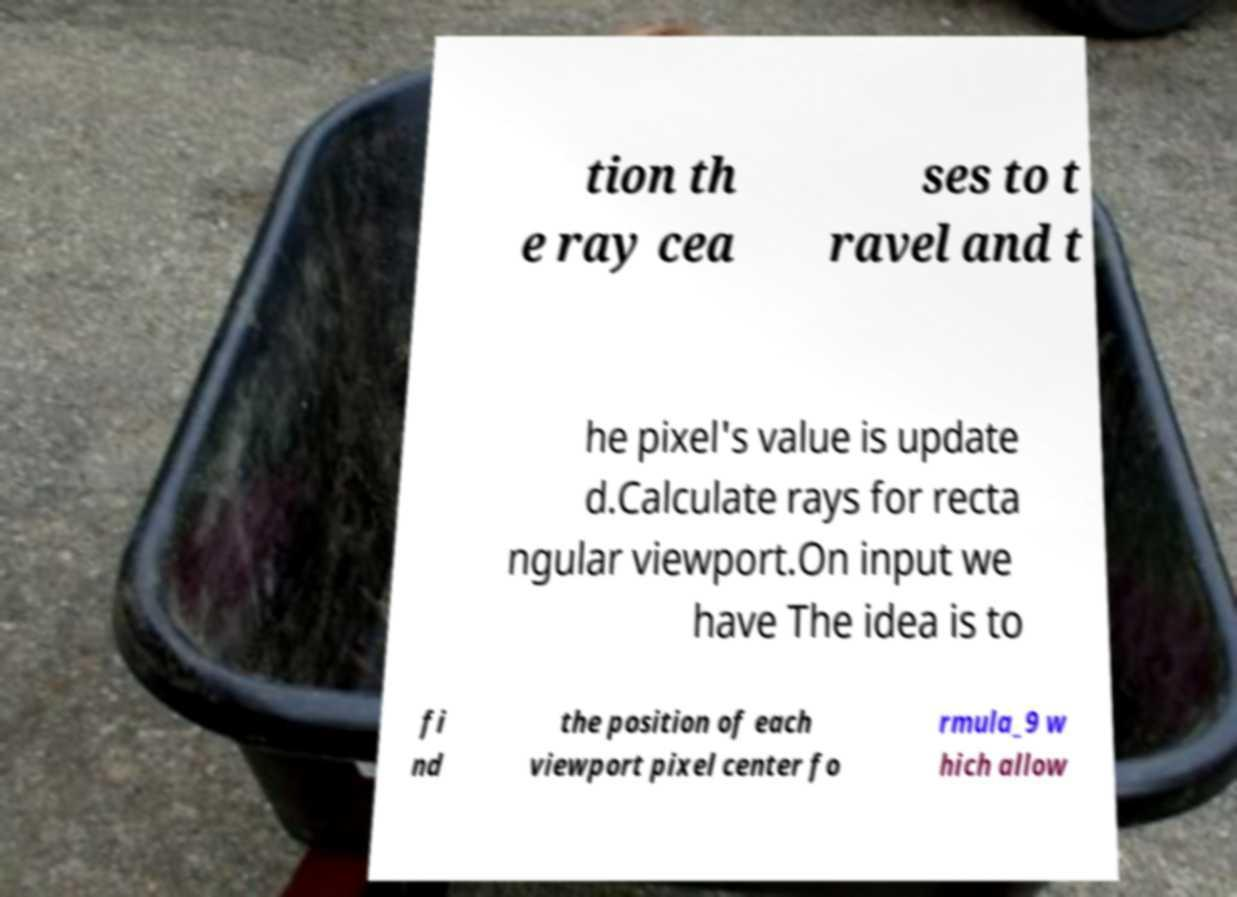For documentation purposes, I need the text within this image transcribed. Could you provide that? tion th e ray cea ses to t ravel and t he pixel's value is update d.Calculate rays for recta ngular viewport.On input we have The idea is to fi nd the position of each viewport pixel center fo rmula_9 w hich allow 